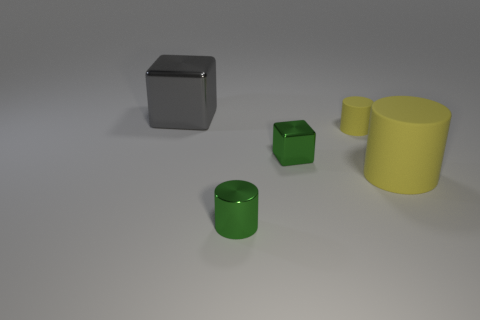Subtract all green metallic cylinders. How many cylinders are left? 2 Subtract all green cylinders. How many cylinders are left? 2 Add 3 green rubber balls. How many objects exist? 8 Subtract all purple balls. How many yellow cylinders are left? 2 Subtract 1 blocks. How many blocks are left? 1 Subtract all cylinders. How many objects are left? 2 Add 2 tiny yellow matte things. How many tiny yellow matte things exist? 3 Subtract 0 red balls. How many objects are left? 5 Subtract all red cylinders. Subtract all yellow spheres. How many cylinders are left? 3 Subtract all green cubes. Subtract all small green metallic blocks. How many objects are left? 3 